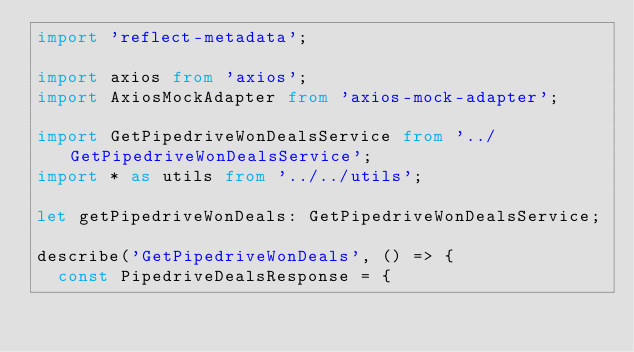Convert code to text. <code><loc_0><loc_0><loc_500><loc_500><_TypeScript_>import 'reflect-metadata';

import axios from 'axios';
import AxiosMockAdapter from 'axios-mock-adapter';

import GetPipedriveWonDealsService from '../GetPipedriveWonDealsService';
import * as utils from '../../utils';

let getPipedriveWonDeals: GetPipedriveWonDealsService;

describe('GetPipedriveWonDeals', () => {
  const PipedriveDealsResponse = {</code> 